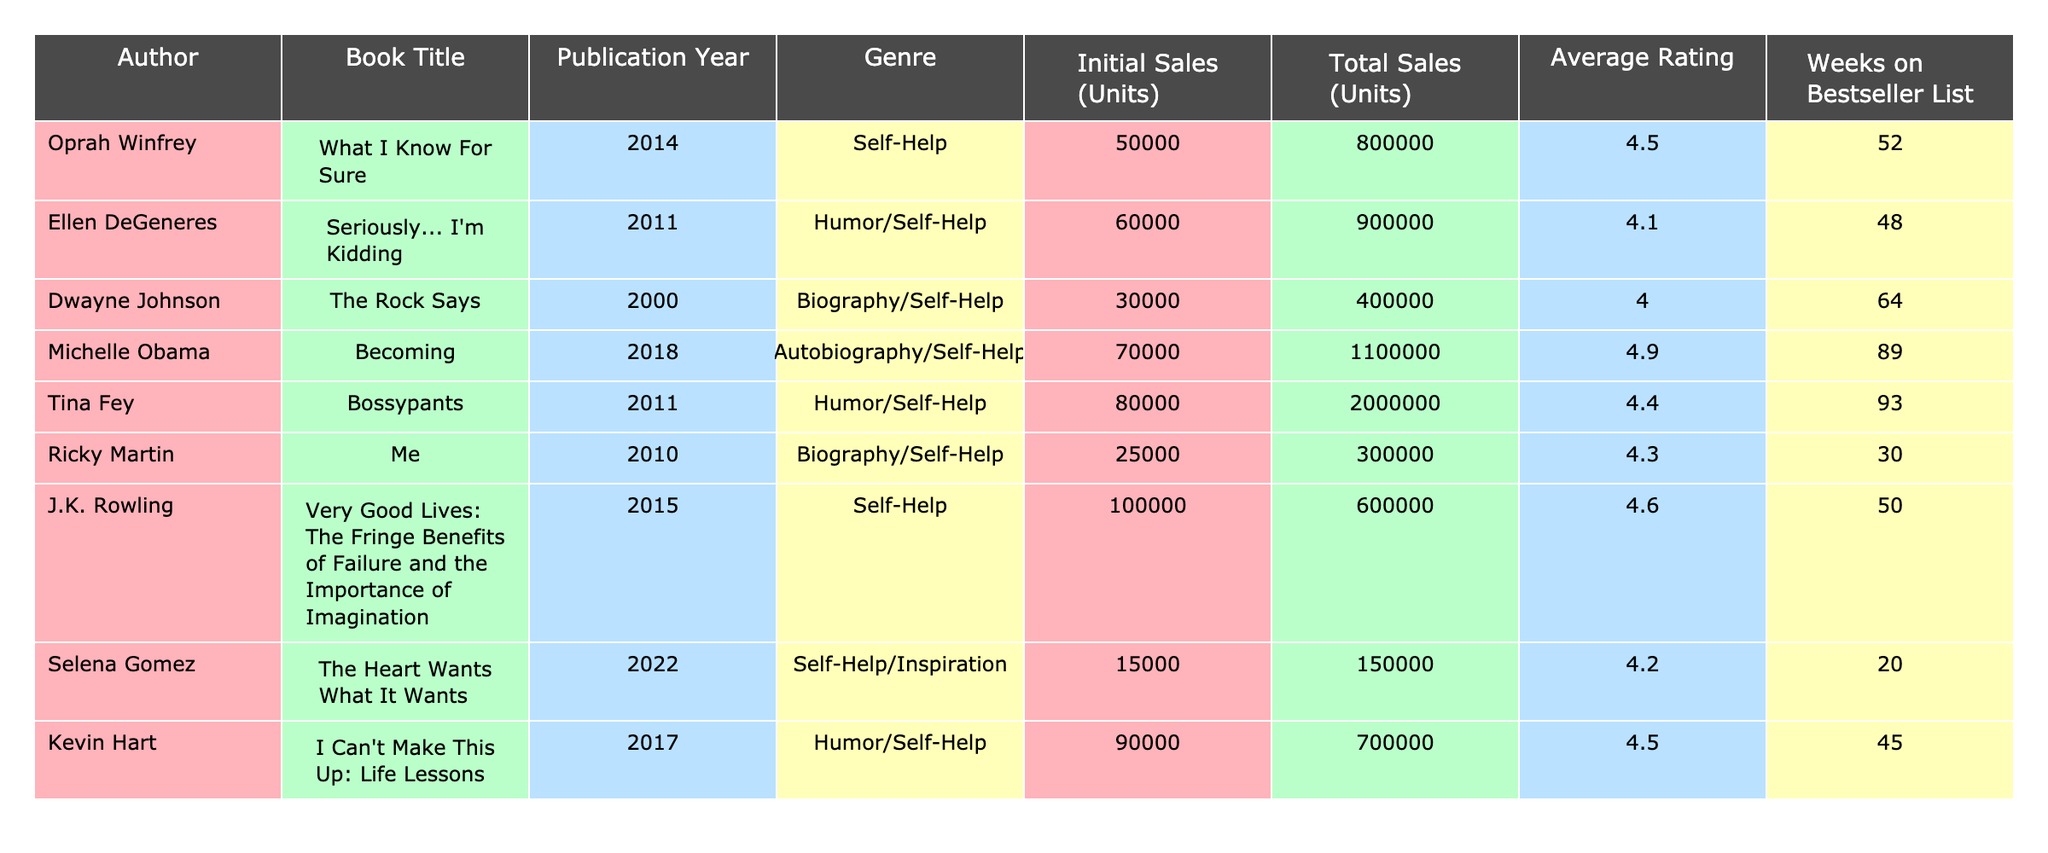What is the total sales figure for Michelle Obama's book? The table shows that Michelle Obama's book "Becoming" has total sales of 1,100,000 units listed in the Total Sales column.
Answer: 1,100,000 Which author has the highest average rating? By examining the Average Rating column, Michelle Obama has an average rating of 4.9, which is the highest among all authors listed.
Answer: 4.9 How many weeks did Tina Fey's book stay on the bestseller list? The table indicates that Tina Fey's book "Bossypants" was on the bestseller list for 93 weeks, as shown in the Weeks on Bestseller List column.
Answer: 93 Is the total sales for Ricky Martin's book greater than 350,000 units? The table lists Ricky Martin's total sales at 300,000 units, which is not greater than 350,000 units, so the answer is no.
Answer: No What is the difference in total sales between Oprah Winfrey's and Ellen DeGeneres's books? Oprah Winfrey's book sold 800,000 units and Ellen DeGeneres's sold 900,000 units. The difference is 900,000 - 800,000 = 100,000 units.
Answer: 100,000 Which book had initial sales of 50,000 units and what is its average rating? The table shows that "What I Know For Sure" by Oprah Winfrey had initial sales of 50,000 units and an average rating of 4.5.
Answer: 4.5 Which two authors had more than 800,000 total sales? By checking the Total Sales column, Michelle Obama (1,100,000) and Tina Fey (2,000,000) both had total sales over 800,000.
Answer: Michelle Obama and Tina Fey If you average the total sales of all books listed, what value do you get? To find the average, add all total sales figures (800,000 + 900,000 + 400,000 + 1,100,000 + 2,000,000 + 300,000 + 600,000 + 150,000 + 700,000 = 6,100,000) and divide by the number of books (9). This gives an average of 6,100,000 / 9 ≈ 677,778.
Answer: 677,778 Does the author with the most weeks on the bestseller list also have the highest total sales? While Michelle Obama has the most weeks (89) and the highest total sales (1,100,000), the author with the highest weeks is Tina Fey who also has high sales (2,000,000). Hence, they are different.
Answer: No 